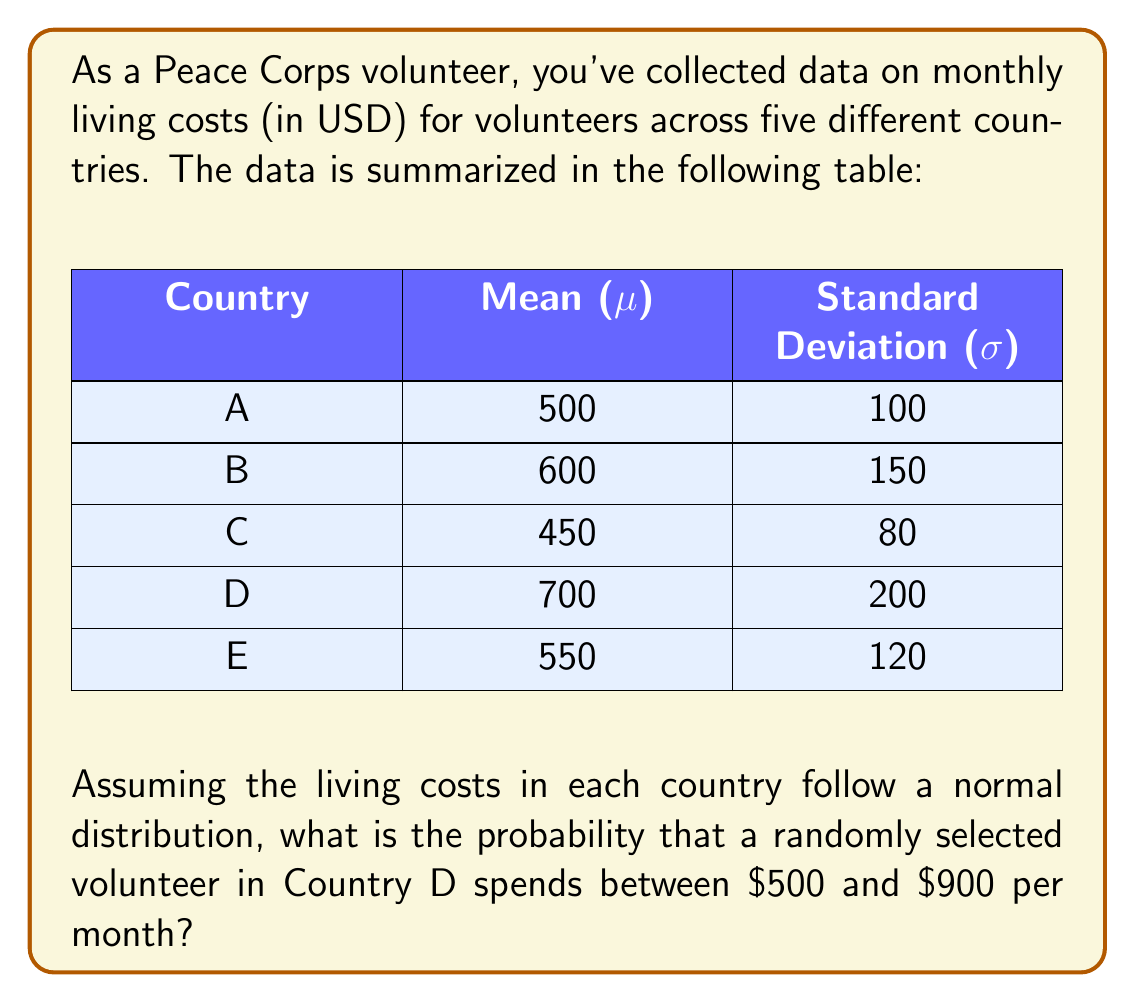Show me your answer to this math problem. To solve this problem, we'll use the properties of the normal distribution and the z-score formula. Here's a step-by-step approach:

1) We're dealing with Country D, where:
   $\mu = 700$ (mean)
   $\sigma = 200$ (standard deviation)

2) We need to find the probability of spending between $500 and $900.

3) First, let's calculate the z-scores for these values:

   For $x_1 = 500$:
   $$z_1 = \frac{x_1 - \mu}{\sigma} = \frac{500 - 700}{200} = -1$$

   For $x_2 = 900$:
   $$z_2 = \frac{x_2 - \mu}{\sigma} = \frac{900 - 700}{200} = 1$$

4) Now, we need to find the area under the standard normal curve between $z = -1$ and $z = 1$.

5) This can be done by finding the area from $z = 0$ to $z = 1$ and doubling it (due to symmetry of the normal distribution).

6) Using a standard normal table or calculator:
   $P(0 < Z < 1) \approx 0.3413$

7) Therefore, the probability of spending between $500 and $900 is:
   $P(-1 < Z < 1) = 2 * 0.3413 = 0.6826$

Thus, there's approximately a 68.26% chance that a randomly selected volunteer in Country D spends between $500 and $900 per month.
Answer: 0.6826 or 68.26% 